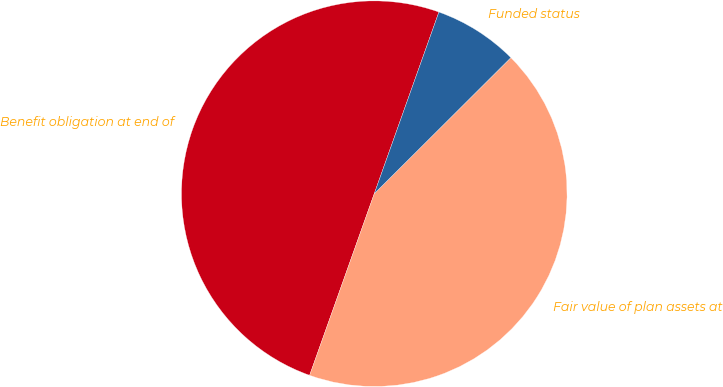Convert chart to OTSL. <chart><loc_0><loc_0><loc_500><loc_500><pie_chart><fcel>Benefit obligation at end of<fcel>Fair value of plan assets at<fcel>Funded status<nl><fcel>50.0%<fcel>42.91%<fcel>7.09%<nl></chart> 